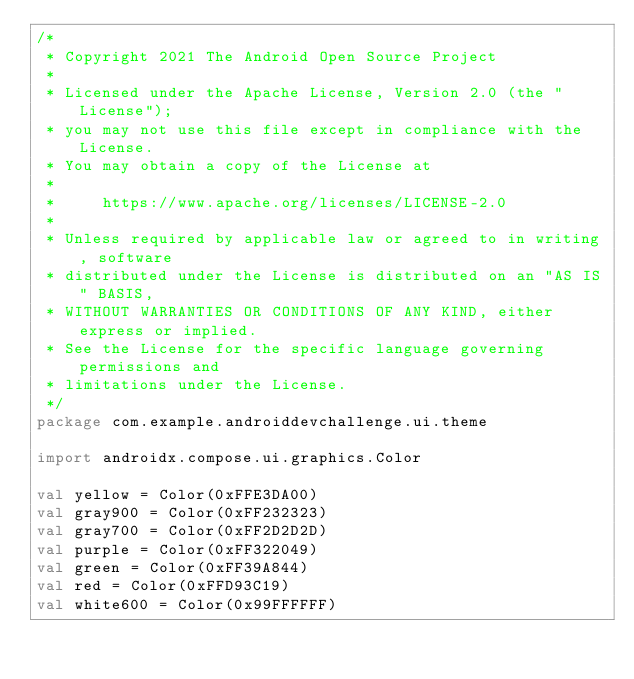Convert code to text. <code><loc_0><loc_0><loc_500><loc_500><_Kotlin_>/*
 * Copyright 2021 The Android Open Source Project
 *
 * Licensed under the Apache License, Version 2.0 (the "License");
 * you may not use this file except in compliance with the License.
 * You may obtain a copy of the License at
 *
 *     https://www.apache.org/licenses/LICENSE-2.0
 *
 * Unless required by applicable law or agreed to in writing, software
 * distributed under the License is distributed on an "AS IS" BASIS,
 * WITHOUT WARRANTIES OR CONDITIONS OF ANY KIND, either express or implied.
 * See the License for the specific language governing permissions and
 * limitations under the License.
 */
package com.example.androiddevchallenge.ui.theme

import androidx.compose.ui.graphics.Color

val yellow = Color(0xFFE3DA00)
val gray900 = Color(0xFF232323)
val gray700 = Color(0xFF2D2D2D)
val purple = Color(0xFF322049)
val green = Color(0xFF39A844)
val red = Color(0xFFD93C19)
val white600 = Color(0x99FFFFFF)
</code> 